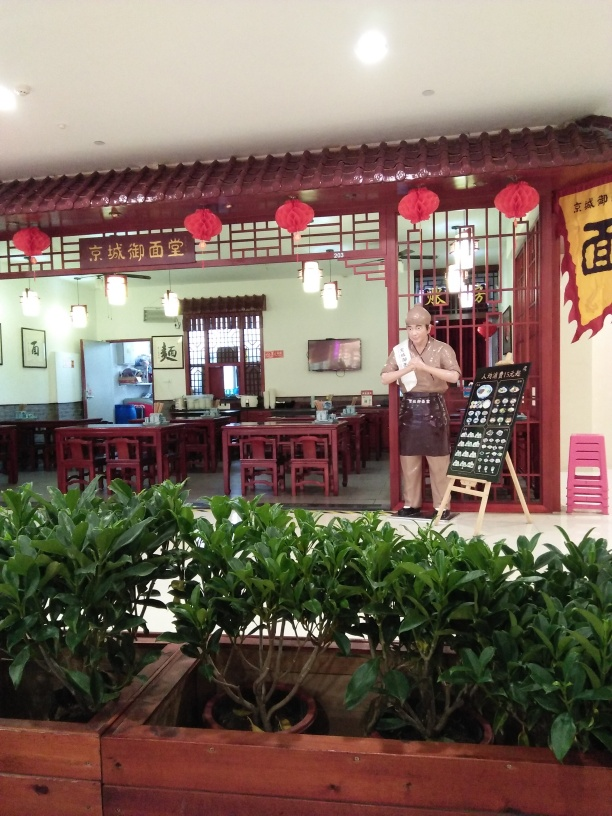Is the overall quality of the image good? The overall quality of the image is quite good, as it is clear and well-lit, providing a detailed view of the interior of a traditionally styled restaurant with an individual standing by an easel menu board. The natural lighting from the windows illuminates the scene without overexposure, preserving the nuances in color and texture, such as the rich wooden tones of the furniture and decor, and the vibrant green of the plants in the foreground. 